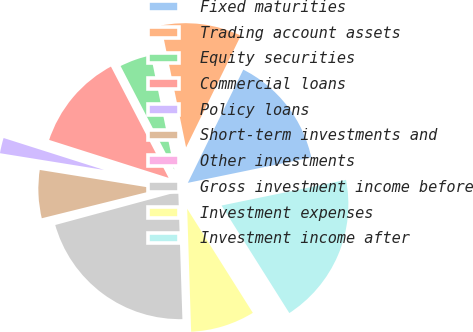Convert chart to OTSL. <chart><loc_0><loc_0><loc_500><loc_500><pie_chart><fcel>Fixed maturities<fcel>Trading account assets<fcel>Equity securities<fcel>Commercial loans<fcel>Policy loans<fcel>Short-term investments and<fcel>Other investments<fcel>Gross investment income before<fcel>Investment expenses<fcel>Investment income after<nl><fcel>14.52%<fcel>10.47%<fcel>4.39%<fcel>12.49%<fcel>2.36%<fcel>6.41%<fcel>0.33%<fcel>21.31%<fcel>8.44%<fcel>19.28%<nl></chart> 